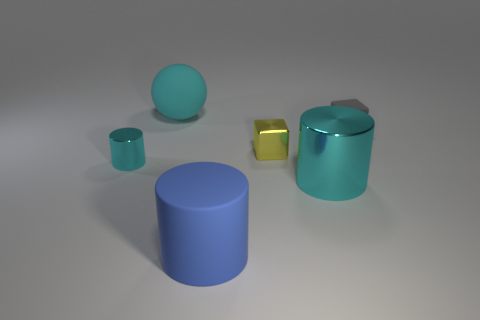Add 4 big blue rubber cylinders. How many objects exist? 10 Subtract all balls. How many objects are left? 5 Add 5 small yellow things. How many small yellow things are left? 6 Add 1 small cyan objects. How many small cyan objects exist? 2 Subtract 0 red cylinders. How many objects are left? 6 Subtract all large blue matte cylinders. Subtract all gray matte blocks. How many objects are left? 4 